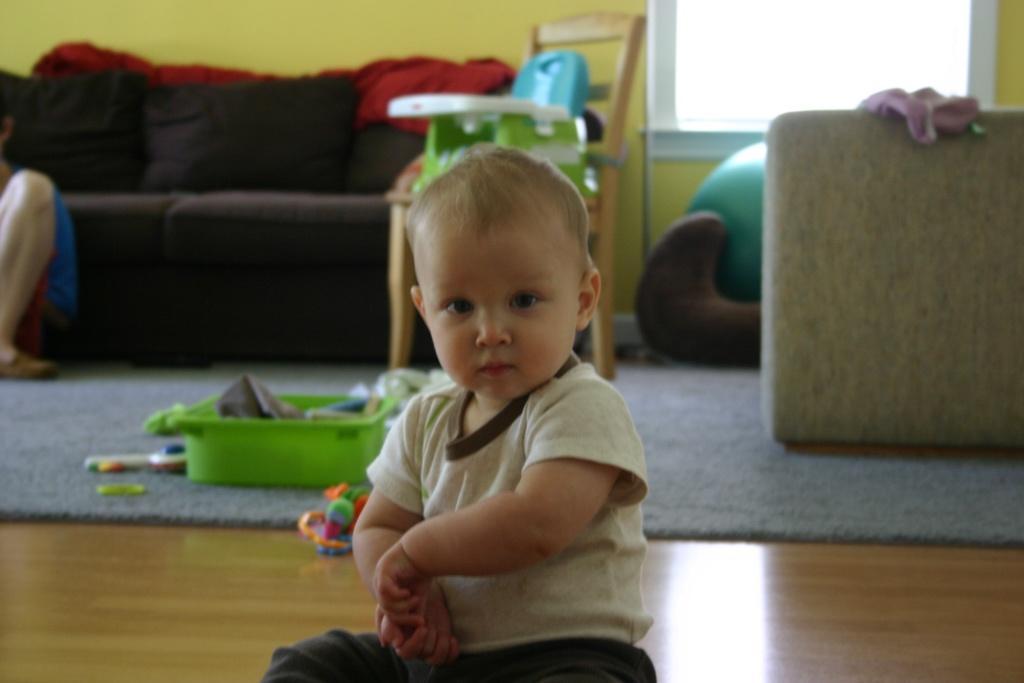How would you summarize this image in a sentence or two? In the middle of the image there is a baby sitting on the floor. Behind the baby there is a floor mat with green tray and toys. There is a wooden chair with an object on it. And also there is a sofa with red cloth. In front of the sofa there is a person sitting on the left side. On the right side of the image there is a sofa with cloth. In the background there is a wall with windows. And also there is an object in front of the window. 